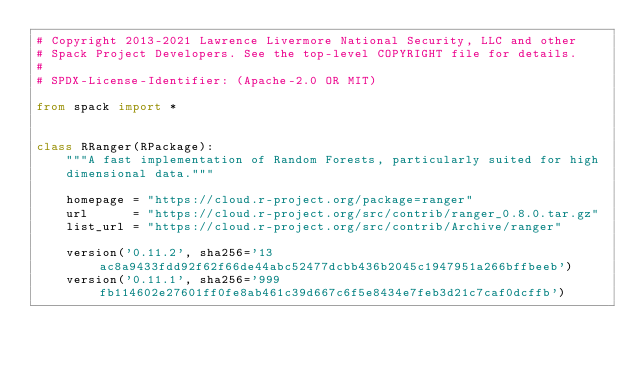Convert code to text. <code><loc_0><loc_0><loc_500><loc_500><_Python_># Copyright 2013-2021 Lawrence Livermore National Security, LLC and other
# Spack Project Developers. See the top-level COPYRIGHT file for details.
#
# SPDX-License-Identifier: (Apache-2.0 OR MIT)

from spack import *


class RRanger(RPackage):
    """A fast implementation of Random Forests, particularly suited for high
    dimensional data."""

    homepage = "https://cloud.r-project.org/package=ranger"
    url      = "https://cloud.r-project.org/src/contrib/ranger_0.8.0.tar.gz"
    list_url = "https://cloud.r-project.org/src/contrib/Archive/ranger"

    version('0.11.2', sha256='13ac8a9433fdd92f62f66de44abc52477dcbb436b2045c1947951a266bffbeeb')
    version('0.11.1', sha256='999fb114602e27601ff0fe8ab461c39d667c6f5e8434e7feb3d21c7caf0dcffb')</code> 